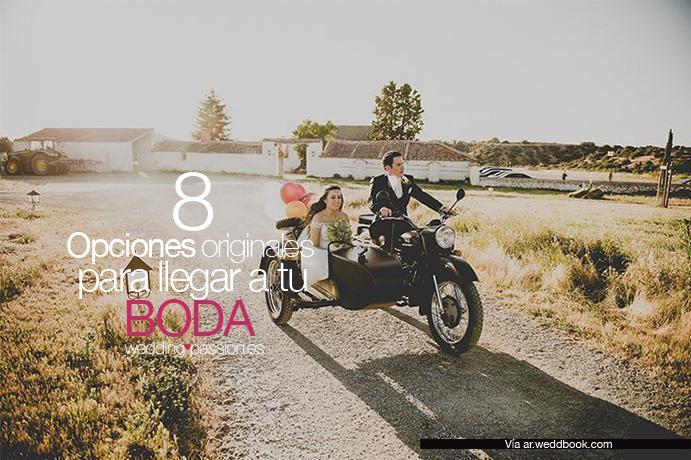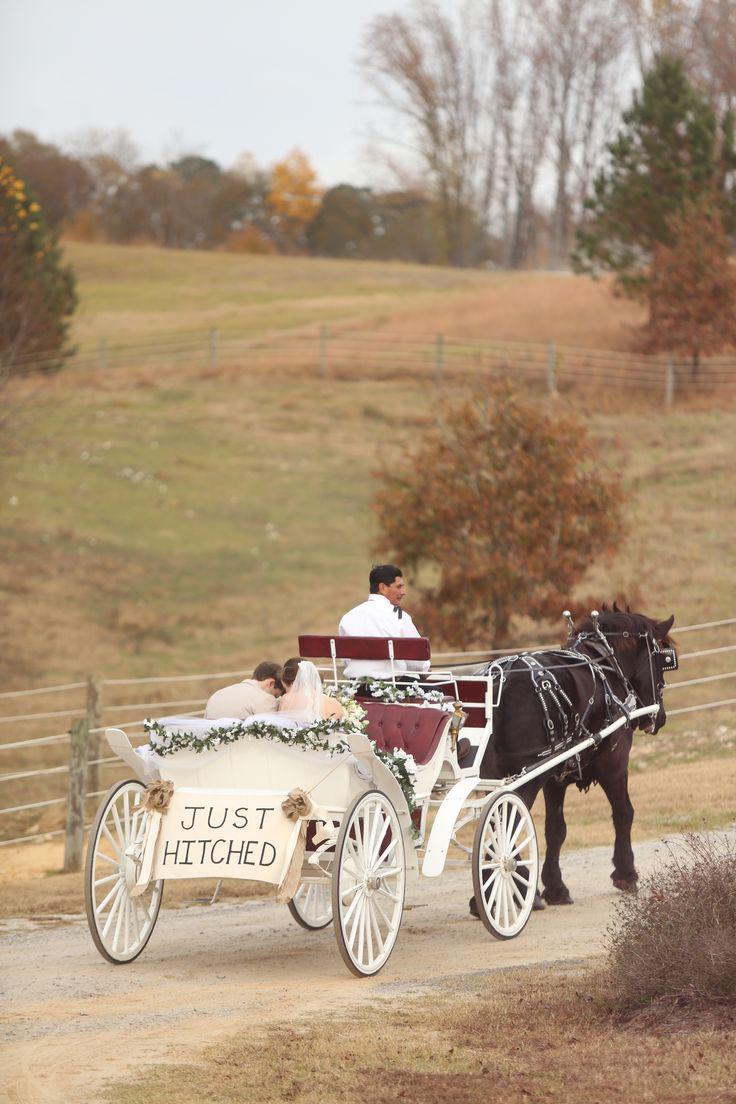The first image is the image on the left, the second image is the image on the right. Given the left and right images, does the statement "The horse carriage are facing opposite directions from each other." hold true? Answer yes or no. No. 